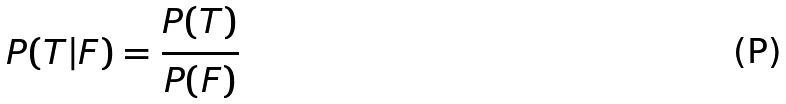<formula> <loc_0><loc_0><loc_500><loc_500>P ( T | F ) = \frac { P ( T ) } { P ( F ) }</formula> 